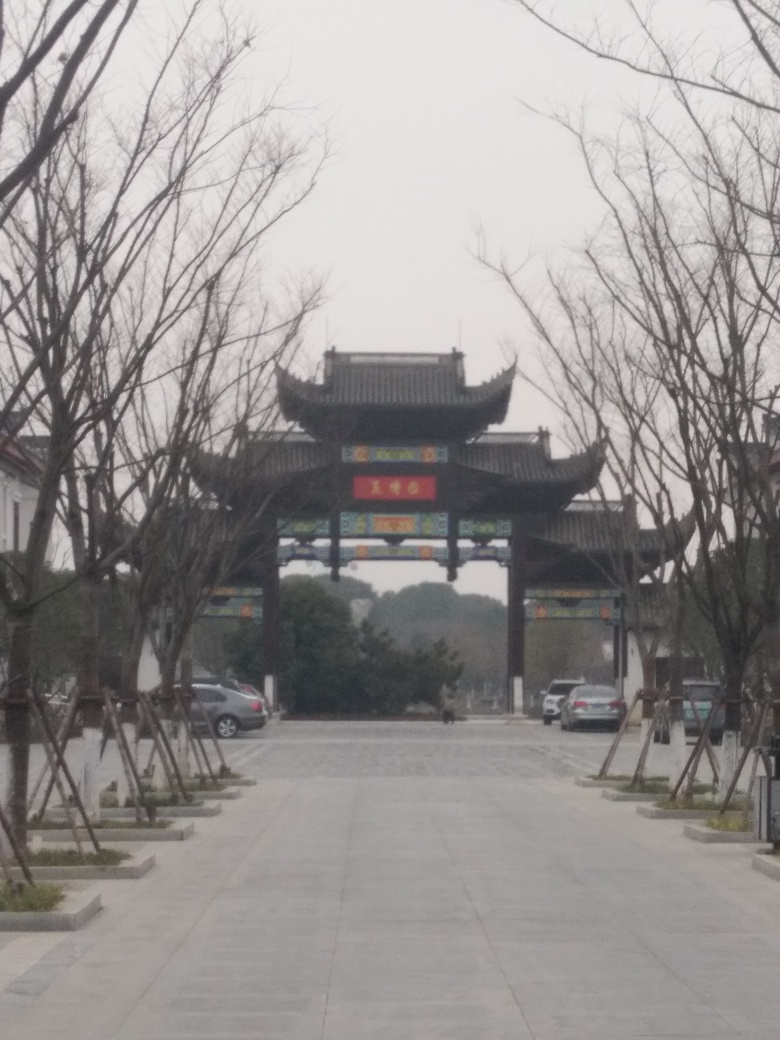Can you describe the architectural style of the gate? The gate exhibits characteristics of traditional Chinese architecture, commonly found in historical buildings and cultural sites. It features a large central archway framed by additional smaller arches, and it's topped by a sweeping, two-tiered roof with upturned eaves, which is typical of classic Chinese construction styles. 